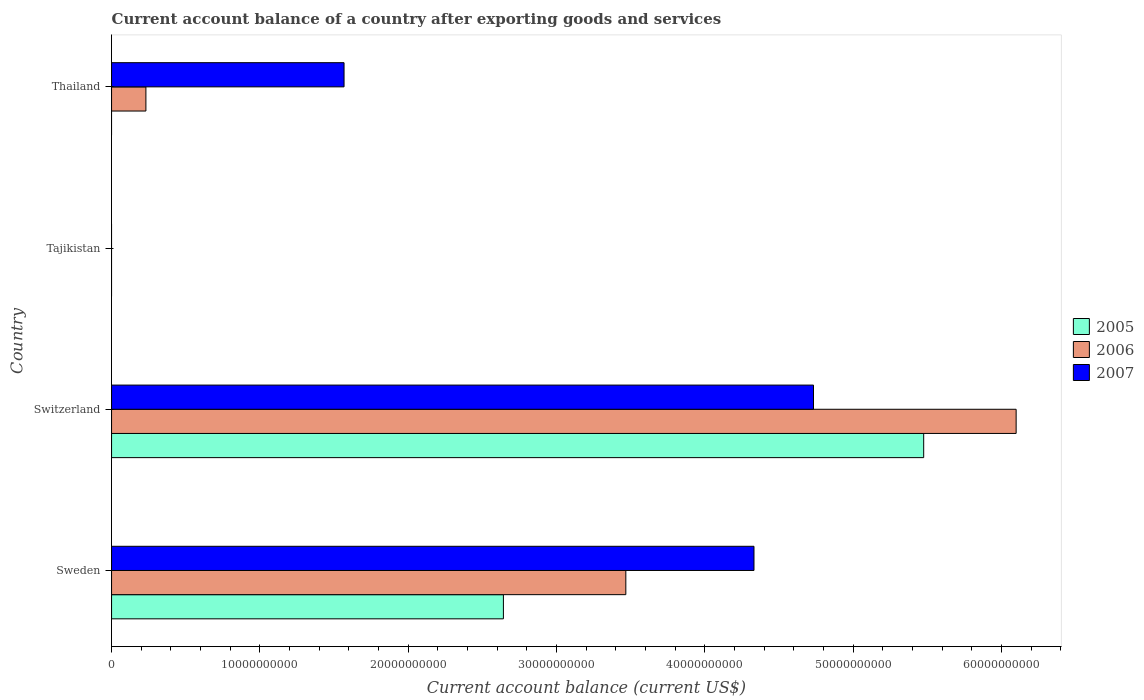How many different coloured bars are there?
Make the answer very short. 3. Are the number of bars per tick equal to the number of legend labels?
Make the answer very short. No. How many bars are there on the 3rd tick from the bottom?
Offer a terse response. 0. In how many cases, is the number of bars for a given country not equal to the number of legend labels?
Give a very brief answer. 2. What is the account balance in 2007 in Thailand?
Your answer should be compact. 1.57e+1. Across all countries, what is the maximum account balance in 2005?
Your answer should be compact. 5.48e+1. In which country was the account balance in 2005 maximum?
Offer a terse response. Switzerland. What is the total account balance in 2007 in the graph?
Provide a succinct answer. 1.06e+11. What is the difference between the account balance in 2007 in Sweden and that in Thailand?
Make the answer very short. 2.76e+1. What is the difference between the account balance in 2007 in Switzerland and the account balance in 2005 in Tajikistan?
Offer a very short reply. 4.73e+1. What is the average account balance in 2007 per country?
Make the answer very short. 2.66e+1. What is the difference between the account balance in 2006 and account balance in 2007 in Thailand?
Keep it short and to the point. -1.34e+1. In how many countries, is the account balance in 2006 greater than 40000000000 US$?
Offer a terse response. 1. What is the ratio of the account balance in 2005 in Sweden to that in Switzerland?
Your answer should be very brief. 0.48. Is the difference between the account balance in 2006 in Switzerland and Thailand greater than the difference between the account balance in 2007 in Switzerland and Thailand?
Your answer should be very brief. Yes. What is the difference between the highest and the second highest account balance in 2006?
Provide a short and direct response. 2.63e+1. What is the difference between the highest and the lowest account balance in 2006?
Ensure brevity in your answer.  6.10e+1. Is it the case that in every country, the sum of the account balance in 2006 and account balance in 2007 is greater than the account balance in 2005?
Offer a terse response. No. How many bars are there?
Ensure brevity in your answer.  8. Does the graph contain any zero values?
Your response must be concise. Yes. Does the graph contain grids?
Your answer should be very brief. No. How many legend labels are there?
Give a very brief answer. 3. What is the title of the graph?
Offer a terse response. Current account balance of a country after exporting goods and services. Does "2006" appear as one of the legend labels in the graph?
Provide a short and direct response. Yes. What is the label or title of the X-axis?
Your response must be concise. Current account balance (current US$). What is the Current account balance (current US$) of 2005 in Sweden?
Your answer should be very brief. 2.64e+1. What is the Current account balance (current US$) of 2006 in Sweden?
Give a very brief answer. 3.47e+1. What is the Current account balance (current US$) of 2007 in Sweden?
Make the answer very short. 4.33e+1. What is the Current account balance (current US$) in 2005 in Switzerland?
Provide a short and direct response. 5.48e+1. What is the Current account balance (current US$) of 2006 in Switzerland?
Offer a terse response. 6.10e+1. What is the Current account balance (current US$) of 2007 in Switzerland?
Provide a succinct answer. 4.73e+1. What is the Current account balance (current US$) in 2005 in Tajikistan?
Make the answer very short. 0. What is the Current account balance (current US$) of 2006 in Tajikistan?
Ensure brevity in your answer.  0. What is the Current account balance (current US$) in 2006 in Thailand?
Give a very brief answer. 2.32e+09. What is the Current account balance (current US$) in 2007 in Thailand?
Keep it short and to the point. 1.57e+1. Across all countries, what is the maximum Current account balance (current US$) of 2005?
Give a very brief answer. 5.48e+1. Across all countries, what is the maximum Current account balance (current US$) of 2006?
Make the answer very short. 6.10e+1. Across all countries, what is the maximum Current account balance (current US$) of 2007?
Your response must be concise. 4.73e+1. Across all countries, what is the minimum Current account balance (current US$) in 2006?
Provide a succinct answer. 0. Across all countries, what is the minimum Current account balance (current US$) of 2007?
Provide a succinct answer. 0. What is the total Current account balance (current US$) of 2005 in the graph?
Ensure brevity in your answer.  8.12e+1. What is the total Current account balance (current US$) in 2006 in the graph?
Your answer should be very brief. 9.80e+1. What is the total Current account balance (current US$) of 2007 in the graph?
Offer a very short reply. 1.06e+11. What is the difference between the Current account balance (current US$) in 2005 in Sweden and that in Switzerland?
Provide a short and direct response. -2.83e+1. What is the difference between the Current account balance (current US$) in 2006 in Sweden and that in Switzerland?
Offer a terse response. -2.63e+1. What is the difference between the Current account balance (current US$) in 2007 in Sweden and that in Switzerland?
Provide a succinct answer. -4.01e+09. What is the difference between the Current account balance (current US$) of 2006 in Sweden and that in Thailand?
Your response must be concise. 3.24e+1. What is the difference between the Current account balance (current US$) in 2007 in Sweden and that in Thailand?
Ensure brevity in your answer.  2.76e+1. What is the difference between the Current account balance (current US$) of 2006 in Switzerland and that in Thailand?
Make the answer very short. 5.87e+1. What is the difference between the Current account balance (current US$) of 2007 in Switzerland and that in Thailand?
Ensure brevity in your answer.  3.17e+1. What is the difference between the Current account balance (current US$) of 2005 in Sweden and the Current account balance (current US$) of 2006 in Switzerland?
Provide a succinct answer. -3.46e+1. What is the difference between the Current account balance (current US$) in 2005 in Sweden and the Current account balance (current US$) in 2007 in Switzerland?
Give a very brief answer. -2.09e+1. What is the difference between the Current account balance (current US$) in 2006 in Sweden and the Current account balance (current US$) in 2007 in Switzerland?
Offer a very short reply. -1.27e+1. What is the difference between the Current account balance (current US$) in 2005 in Sweden and the Current account balance (current US$) in 2006 in Thailand?
Keep it short and to the point. 2.41e+1. What is the difference between the Current account balance (current US$) of 2005 in Sweden and the Current account balance (current US$) of 2007 in Thailand?
Keep it short and to the point. 1.07e+1. What is the difference between the Current account balance (current US$) of 2006 in Sweden and the Current account balance (current US$) of 2007 in Thailand?
Your answer should be compact. 1.90e+1. What is the difference between the Current account balance (current US$) of 2005 in Switzerland and the Current account balance (current US$) of 2006 in Thailand?
Provide a succinct answer. 5.24e+1. What is the difference between the Current account balance (current US$) in 2005 in Switzerland and the Current account balance (current US$) in 2007 in Thailand?
Your response must be concise. 3.91e+1. What is the difference between the Current account balance (current US$) of 2006 in Switzerland and the Current account balance (current US$) of 2007 in Thailand?
Ensure brevity in your answer.  4.53e+1. What is the average Current account balance (current US$) in 2005 per country?
Your response must be concise. 2.03e+1. What is the average Current account balance (current US$) of 2006 per country?
Give a very brief answer. 2.45e+1. What is the average Current account balance (current US$) in 2007 per country?
Offer a terse response. 2.66e+1. What is the difference between the Current account balance (current US$) of 2005 and Current account balance (current US$) of 2006 in Sweden?
Ensure brevity in your answer.  -8.25e+09. What is the difference between the Current account balance (current US$) in 2005 and Current account balance (current US$) in 2007 in Sweden?
Ensure brevity in your answer.  -1.69e+1. What is the difference between the Current account balance (current US$) of 2006 and Current account balance (current US$) of 2007 in Sweden?
Ensure brevity in your answer.  -8.64e+09. What is the difference between the Current account balance (current US$) of 2005 and Current account balance (current US$) of 2006 in Switzerland?
Offer a very short reply. -6.23e+09. What is the difference between the Current account balance (current US$) in 2005 and Current account balance (current US$) in 2007 in Switzerland?
Provide a short and direct response. 7.43e+09. What is the difference between the Current account balance (current US$) in 2006 and Current account balance (current US$) in 2007 in Switzerland?
Your answer should be compact. 1.37e+1. What is the difference between the Current account balance (current US$) of 2006 and Current account balance (current US$) of 2007 in Thailand?
Keep it short and to the point. -1.34e+1. What is the ratio of the Current account balance (current US$) of 2005 in Sweden to that in Switzerland?
Make the answer very short. 0.48. What is the ratio of the Current account balance (current US$) of 2006 in Sweden to that in Switzerland?
Your response must be concise. 0.57. What is the ratio of the Current account balance (current US$) in 2007 in Sweden to that in Switzerland?
Your answer should be compact. 0.92. What is the ratio of the Current account balance (current US$) of 2006 in Sweden to that in Thailand?
Offer a terse response. 14.97. What is the ratio of the Current account balance (current US$) in 2007 in Sweden to that in Thailand?
Your response must be concise. 2.76. What is the ratio of the Current account balance (current US$) in 2006 in Switzerland to that in Thailand?
Offer a very short reply. 26.34. What is the ratio of the Current account balance (current US$) in 2007 in Switzerland to that in Thailand?
Your response must be concise. 3.02. What is the difference between the highest and the second highest Current account balance (current US$) of 2006?
Provide a succinct answer. 2.63e+1. What is the difference between the highest and the second highest Current account balance (current US$) of 2007?
Make the answer very short. 4.01e+09. What is the difference between the highest and the lowest Current account balance (current US$) of 2005?
Keep it short and to the point. 5.48e+1. What is the difference between the highest and the lowest Current account balance (current US$) of 2006?
Provide a short and direct response. 6.10e+1. What is the difference between the highest and the lowest Current account balance (current US$) in 2007?
Provide a short and direct response. 4.73e+1. 